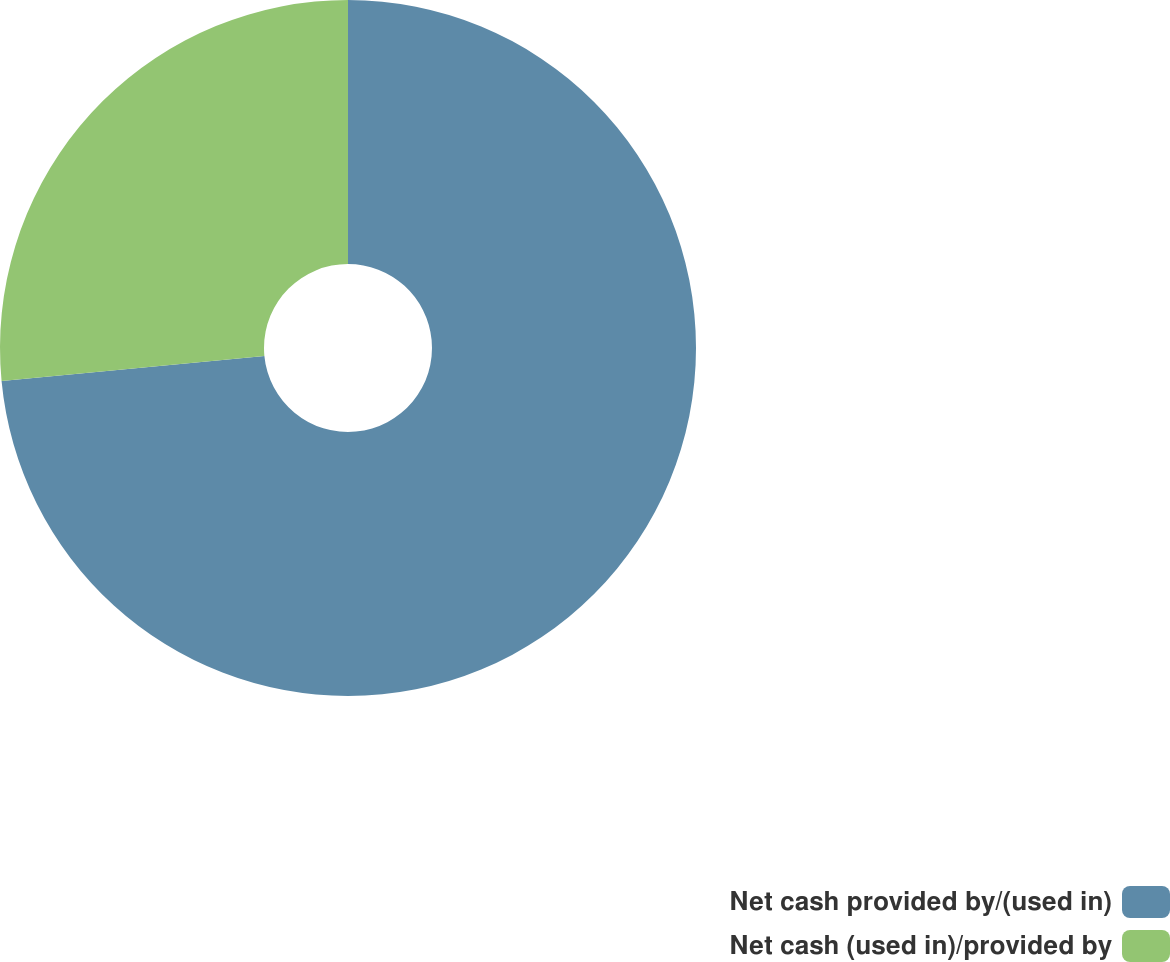<chart> <loc_0><loc_0><loc_500><loc_500><pie_chart><fcel>Net cash provided by/(used in)<fcel>Net cash (used in)/provided by<nl><fcel>73.49%<fcel>26.51%<nl></chart> 